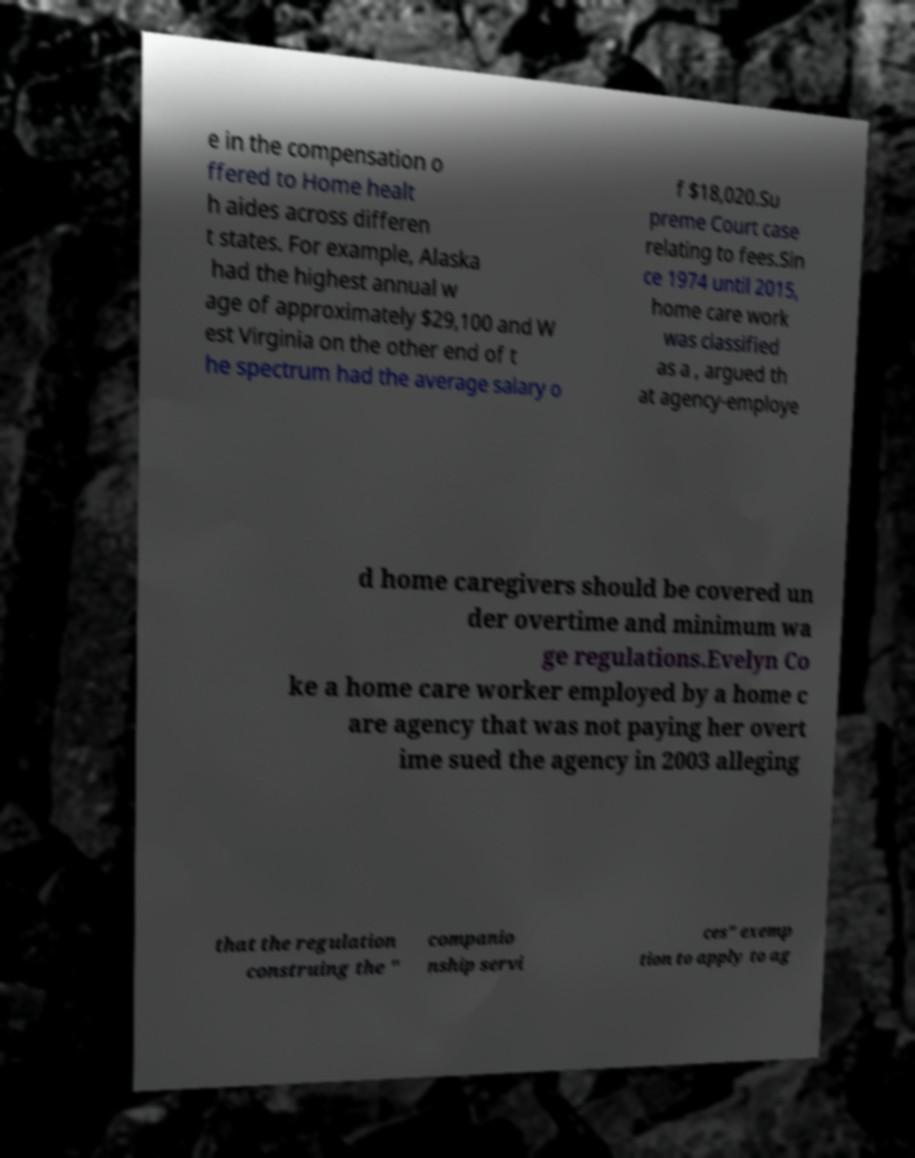There's text embedded in this image that I need extracted. Can you transcribe it verbatim? e in the compensation o ffered to Home healt h aides across differen t states. For example, Alaska had the highest annual w age of approximately $29,100 and W est Virginia on the other end of t he spectrum had the average salary o f $18,020.Su preme Court case relating to fees.Sin ce 1974 until 2015, home care work was classified as a , argued th at agency-employe d home caregivers should be covered un der overtime and minimum wa ge regulations.Evelyn Co ke a home care worker employed by a home c are agency that was not paying her overt ime sued the agency in 2003 alleging that the regulation construing the " companio nship servi ces" exemp tion to apply to ag 